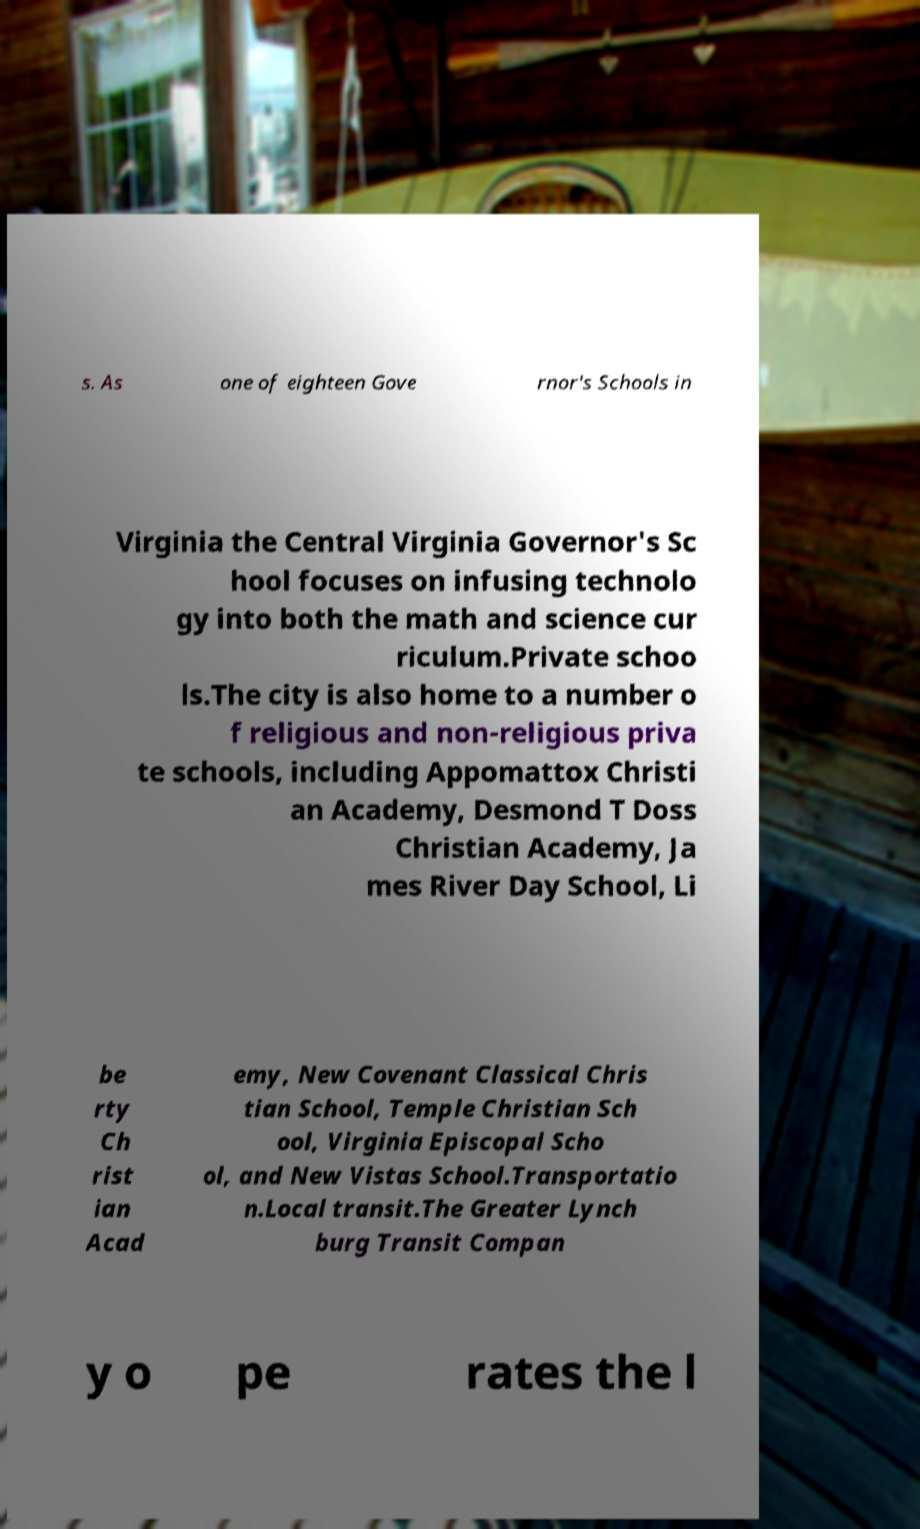There's text embedded in this image that I need extracted. Can you transcribe it verbatim? s. As one of eighteen Gove rnor's Schools in Virginia the Central Virginia Governor's Sc hool focuses on infusing technolo gy into both the math and science cur riculum.Private schoo ls.The city is also home to a number o f religious and non-religious priva te schools, including Appomattox Christi an Academy, Desmond T Doss Christian Academy, Ja mes River Day School, Li be rty Ch rist ian Acad emy, New Covenant Classical Chris tian School, Temple Christian Sch ool, Virginia Episcopal Scho ol, and New Vistas School.Transportatio n.Local transit.The Greater Lynch burg Transit Compan y o pe rates the l 